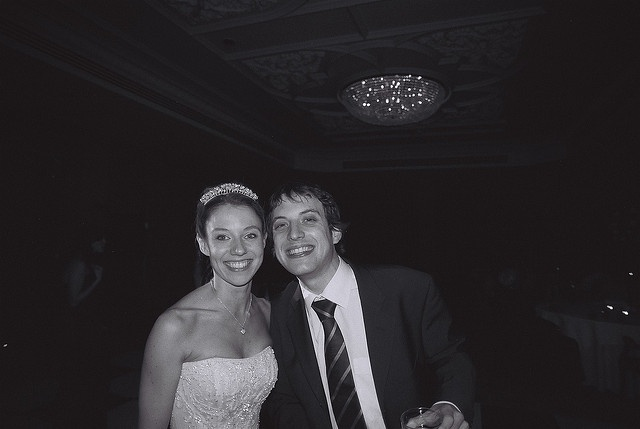Describe the objects in this image and their specific colors. I can see people in black, gray, darkgray, and lightgray tones, people in black, darkgray, and gray tones, tie in black and gray tones, people in black tones, and cup in black and gray tones in this image. 